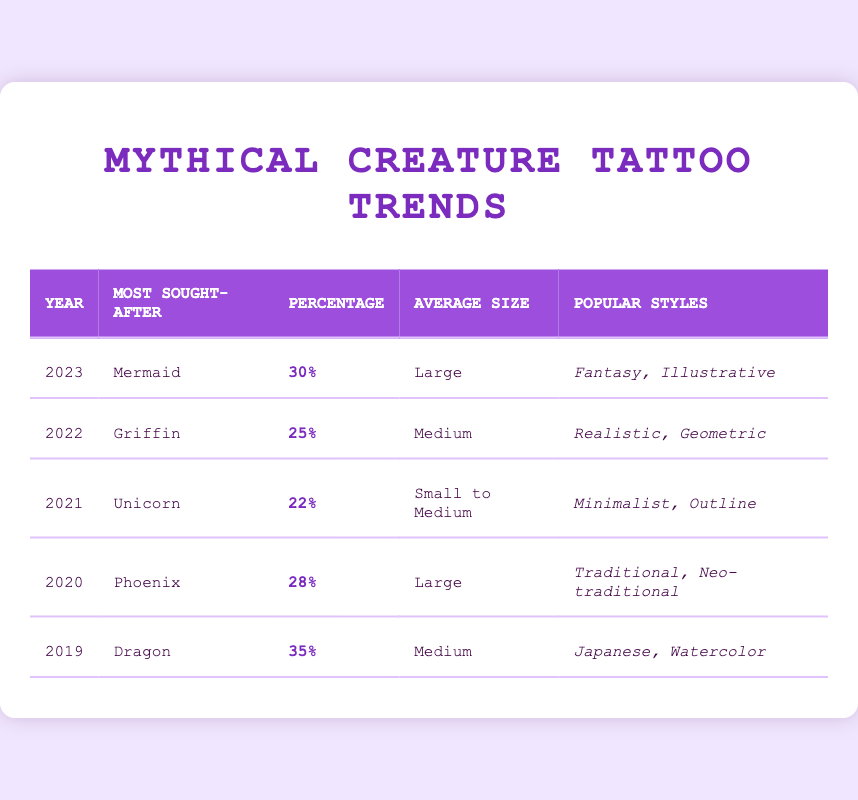What was the most sought-after mythical creature tattoo in 2020? By looking at the "most sought-after" column for the year 2020, it is noted that "Phoenix" was listed.
Answer: Phoenix Which year's tattoo requests had the highest percentage? Throughout the table, the "percentage of requests" for each year is compared. The highest percentage is 35% in 2019, which corresponds to "Dragon."
Answer: 2019 In which year did the Unicorn tattoo become popular, and what was the average size? The table shows that Unicorn tattoos were most sought after in 2021, with an average size categorized as "Small to Medium."
Answer: 2021, Small to Medium How many mythical creature tattoos had a percentage of requests of 25% or more? We check each row for the percentage of requests: 35% (2019), 28% (2020), 30% (2023), and 25% (2022). Therefore, there are four tattoos with 25% or more.
Answer: 4 Is it true that Mermaid tattoos were more popular than Griffin tattoos? Comparing the percentages of requests for Mermaid (30%) and Griffin (25%) tattoos, it is evident that Mermaid tattoos had a higher percentage.
Answer: Yes What is the average percentage of requests for tattoos from 2019 to 2022? To find the average, we sum the percentages of requests: 35% + 28% + 22% + 25% = 110%. Then divide by the number of years, 110% / 4 = 27.5%.
Answer: 27.5% Which mythical creature tattoos had the largest average size? Referring to the "average tattoo size" column, both "Phoenix" (2020) and "Mermaid" (2023) are designated as "Large," making them the largest average size tattoos.
Answer: Phoenix, Mermaid How does the percentage of requests for Unicorn (2021) compare to Dragon (2019)? Unicorn tattoos had a percentage of 22%, while Dragon tattoos had a higher percentage of 35%. This indicates that Dragon tattoos were more popular compared to Unicorn tattoos when the two years are compared.
Answer: Dragon was more popular 